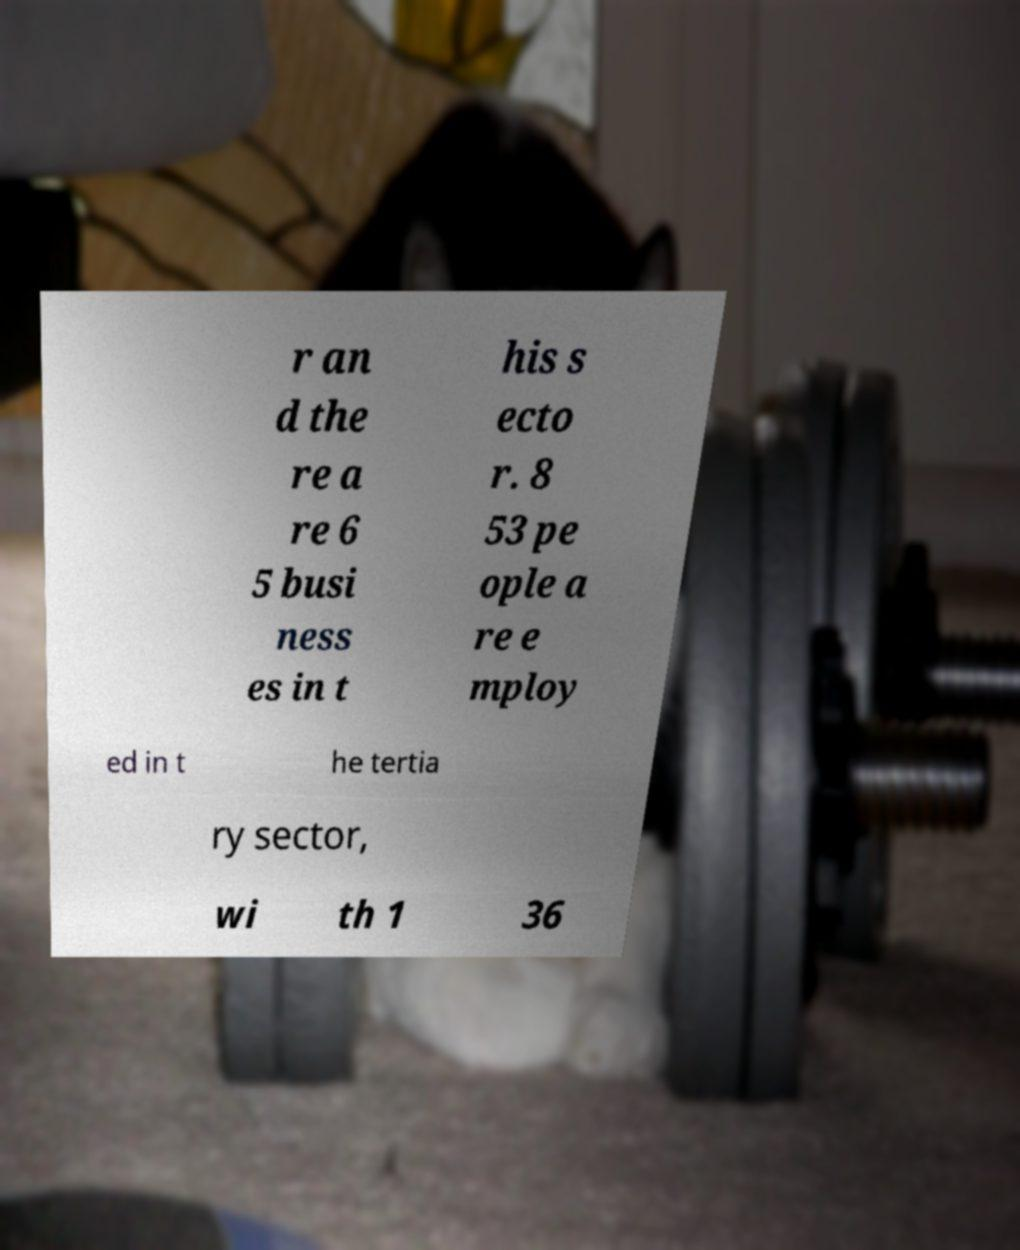Can you accurately transcribe the text from the provided image for me? r an d the re a re 6 5 busi ness es in t his s ecto r. 8 53 pe ople a re e mploy ed in t he tertia ry sector, wi th 1 36 